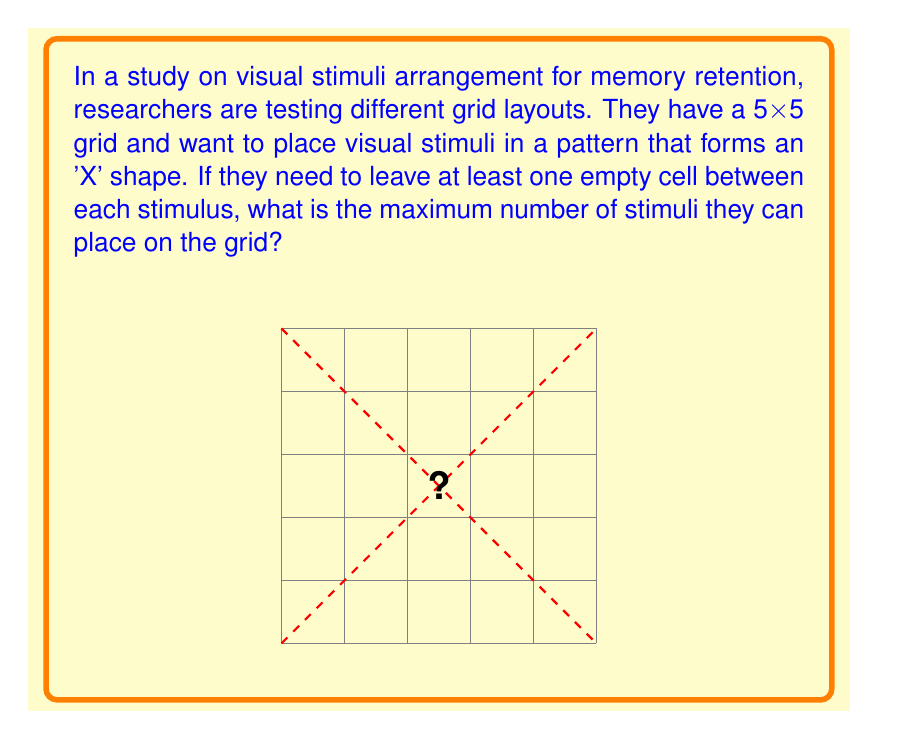Provide a solution to this math problem. Let's approach this step-by-step:

1) The 'X' shape in a 5x5 grid consists of two diagonals:
   - Main diagonal: from top-left to bottom-right
   - Counter diagonal: from top-right to bottom-left

2) These diagonals intersect at the center cell. We can only use one stimulus at this intersection point.

3) For each diagonal, we need to consider the constraint of leaving at least one empty cell between stimuli:

   - In a 5x5 grid, each diagonal has 5 cells.
   - If we place stimuli with one cell gap, we can fit 3 stimuli on each diagonal: at positions 1, 3, and 5.

4) However, we've counted the center cell twice. We need to subtract 1 to avoid double-counting.

5) Therefore, the maximum number of stimuli we can place is:

   $$3 \text{ (from one diagonal)} + 3 \text{ (from the other diagonal)} - 1 \text{ (center overlap)} = 5$$

This arrangement satisfies the 'X' shape requirement and maintains at least one empty cell between each stimulus.
Answer: 5 stimuli 